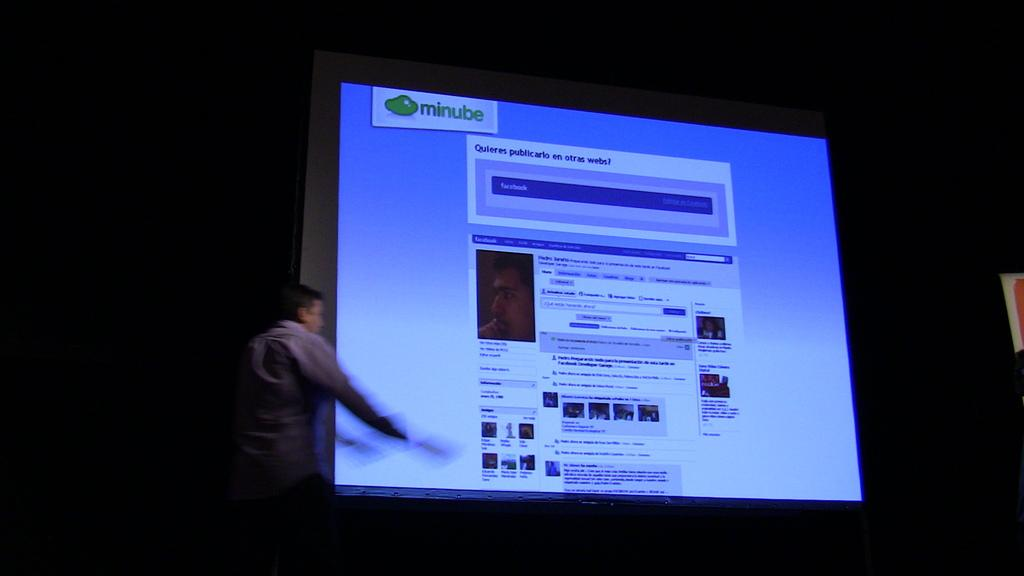Provide a one-sentence caption for the provided image. A man is giving a presentation in front of a screen that says minube. 